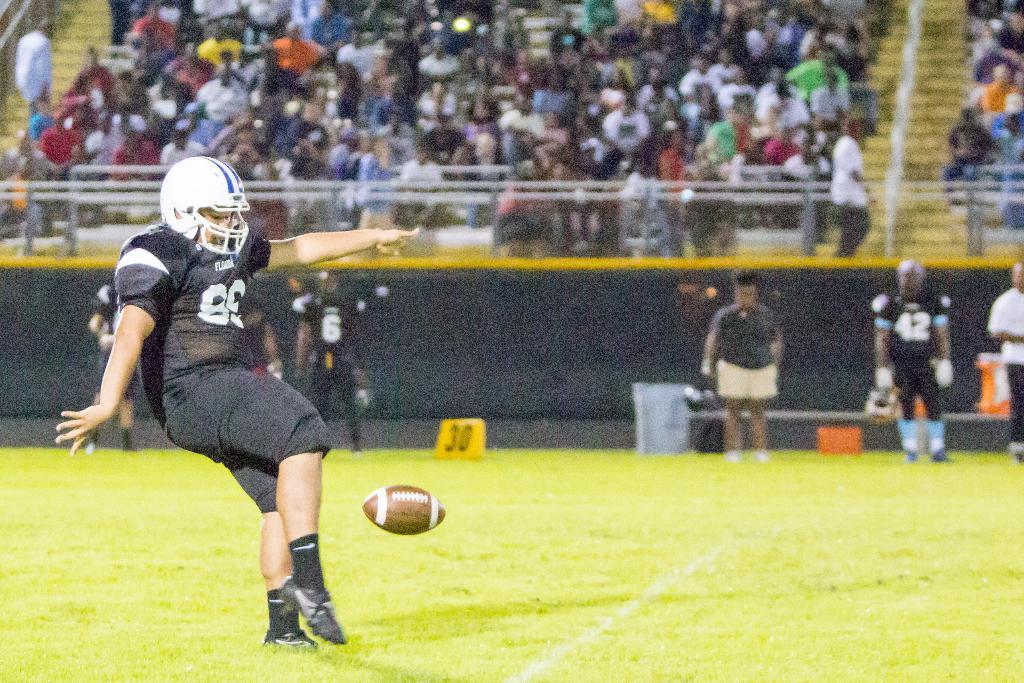How would you summarize this image in a sentence or two? In this image there are persons who are playing Rugby at the middle of the image there is a ball and at the top of the image there are spectators. 